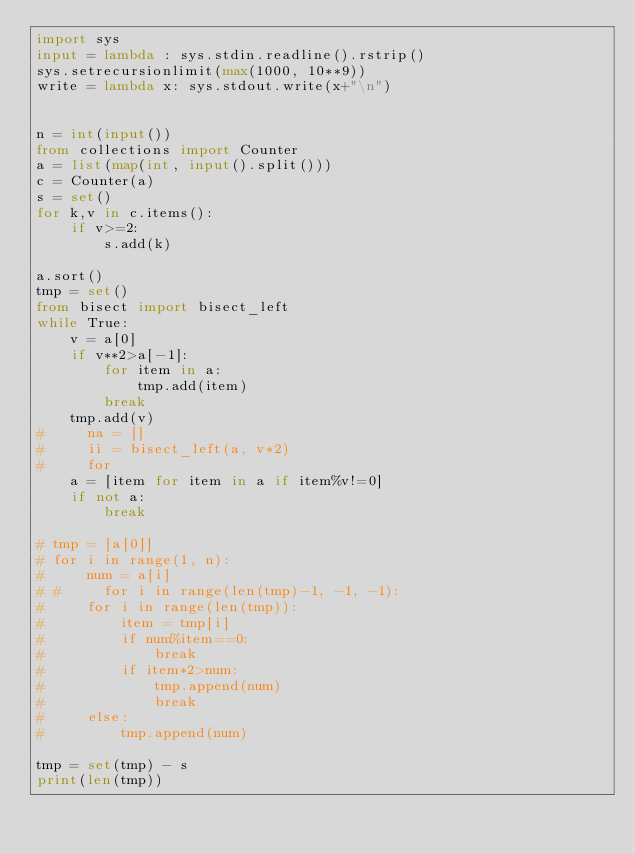<code> <loc_0><loc_0><loc_500><loc_500><_Python_>import sys
input = lambda : sys.stdin.readline().rstrip()
sys.setrecursionlimit(max(1000, 10**9))
write = lambda x: sys.stdout.write(x+"\n")


n = int(input())
from collections import Counter
a = list(map(int, input().split()))
c = Counter(a)
s = set()
for k,v in c.items():
    if v>=2:
        s.add(k)
        
a.sort()
tmp = set()
from bisect import bisect_left
while True:
    v = a[0]
    if v**2>a[-1]:
        for item in a:
            tmp.add(item)
        break
    tmp.add(v)
#     na = []
#     ii = bisect_left(a, v*2)
#     for 
    a = [item for item in a if item%v!=0]
    if not a:
        break

# tmp = [a[0]]
# for i in range(1, n):
#     num = a[i]
# #     for i in range(len(tmp)-1, -1, -1):
#     for i in range(len(tmp)):
#         item = tmp[i]
#         if num%item==0:
#             break
#         if item*2>num:
#             tmp.append(num)
#             break
#     else:
#         tmp.append(num)

tmp = set(tmp) - s
print(len(tmp))</code> 